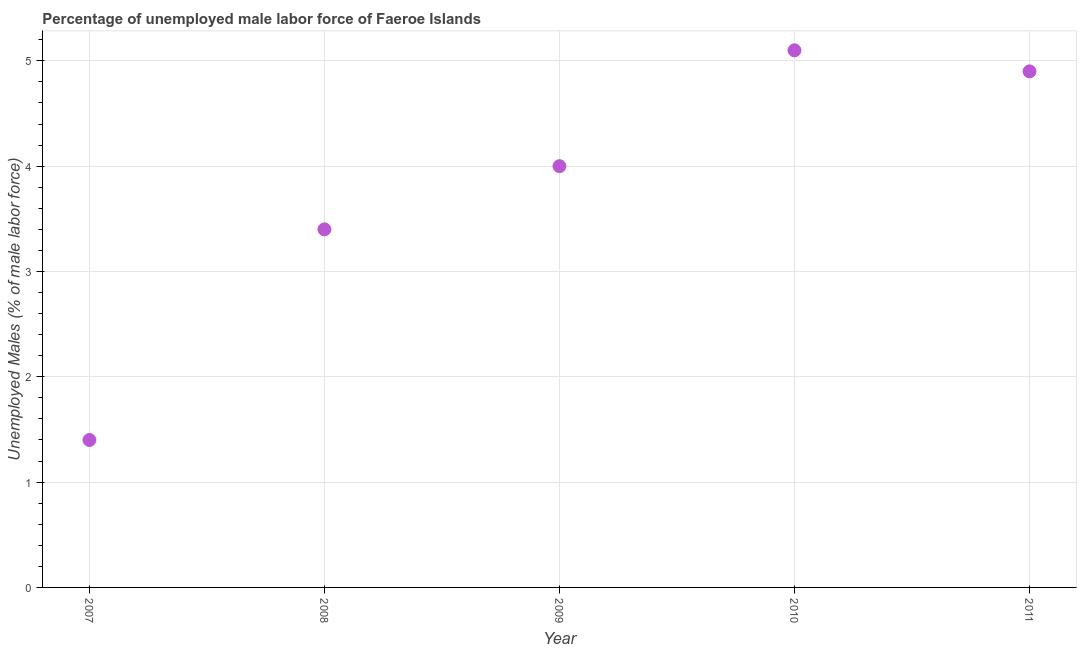What is the total unemployed male labour force in 2008?
Your answer should be very brief. 3.4. Across all years, what is the maximum total unemployed male labour force?
Provide a succinct answer. 5.1. Across all years, what is the minimum total unemployed male labour force?
Offer a very short reply. 1.4. What is the sum of the total unemployed male labour force?
Keep it short and to the point. 18.8. What is the average total unemployed male labour force per year?
Make the answer very short. 3.76. What is the median total unemployed male labour force?
Make the answer very short. 4. What is the ratio of the total unemployed male labour force in 2007 to that in 2011?
Your answer should be compact. 0.29. Is the total unemployed male labour force in 2009 less than that in 2011?
Give a very brief answer. Yes. What is the difference between the highest and the second highest total unemployed male labour force?
Offer a very short reply. 0.2. Is the sum of the total unemployed male labour force in 2007 and 2011 greater than the maximum total unemployed male labour force across all years?
Ensure brevity in your answer.  Yes. What is the difference between the highest and the lowest total unemployed male labour force?
Make the answer very short. 3.7. In how many years, is the total unemployed male labour force greater than the average total unemployed male labour force taken over all years?
Offer a terse response. 3. How many dotlines are there?
Give a very brief answer. 1. What is the difference between two consecutive major ticks on the Y-axis?
Ensure brevity in your answer.  1. What is the title of the graph?
Give a very brief answer. Percentage of unemployed male labor force of Faeroe Islands. What is the label or title of the Y-axis?
Ensure brevity in your answer.  Unemployed Males (% of male labor force). What is the Unemployed Males (% of male labor force) in 2007?
Ensure brevity in your answer.  1.4. What is the Unemployed Males (% of male labor force) in 2008?
Make the answer very short. 3.4. What is the Unemployed Males (% of male labor force) in 2010?
Ensure brevity in your answer.  5.1. What is the Unemployed Males (% of male labor force) in 2011?
Offer a very short reply. 4.9. What is the difference between the Unemployed Males (% of male labor force) in 2007 and 2008?
Ensure brevity in your answer.  -2. What is the difference between the Unemployed Males (% of male labor force) in 2007 and 2009?
Offer a very short reply. -2.6. What is the difference between the Unemployed Males (% of male labor force) in 2007 and 2011?
Your answer should be very brief. -3.5. What is the difference between the Unemployed Males (% of male labor force) in 2008 and 2009?
Offer a terse response. -0.6. What is the difference between the Unemployed Males (% of male labor force) in 2008 and 2010?
Keep it short and to the point. -1.7. What is the difference between the Unemployed Males (% of male labor force) in 2008 and 2011?
Keep it short and to the point. -1.5. What is the difference between the Unemployed Males (% of male labor force) in 2009 and 2010?
Offer a terse response. -1.1. What is the ratio of the Unemployed Males (% of male labor force) in 2007 to that in 2008?
Ensure brevity in your answer.  0.41. What is the ratio of the Unemployed Males (% of male labor force) in 2007 to that in 2009?
Give a very brief answer. 0.35. What is the ratio of the Unemployed Males (% of male labor force) in 2007 to that in 2010?
Make the answer very short. 0.28. What is the ratio of the Unemployed Males (% of male labor force) in 2007 to that in 2011?
Your answer should be compact. 0.29. What is the ratio of the Unemployed Males (% of male labor force) in 2008 to that in 2009?
Give a very brief answer. 0.85. What is the ratio of the Unemployed Males (% of male labor force) in 2008 to that in 2010?
Provide a short and direct response. 0.67. What is the ratio of the Unemployed Males (% of male labor force) in 2008 to that in 2011?
Offer a terse response. 0.69. What is the ratio of the Unemployed Males (% of male labor force) in 2009 to that in 2010?
Give a very brief answer. 0.78. What is the ratio of the Unemployed Males (% of male labor force) in 2009 to that in 2011?
Provide a short and direct response. 0.82. What is the ratio of the Unemployed Males (% of male labor force) in 2010 to that in 2011?
Keep it short and to the point. 1.04. 